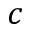Convert formula to latex. <formula><loc_0><loc_0><loc_500><loc_500>c</formula> 